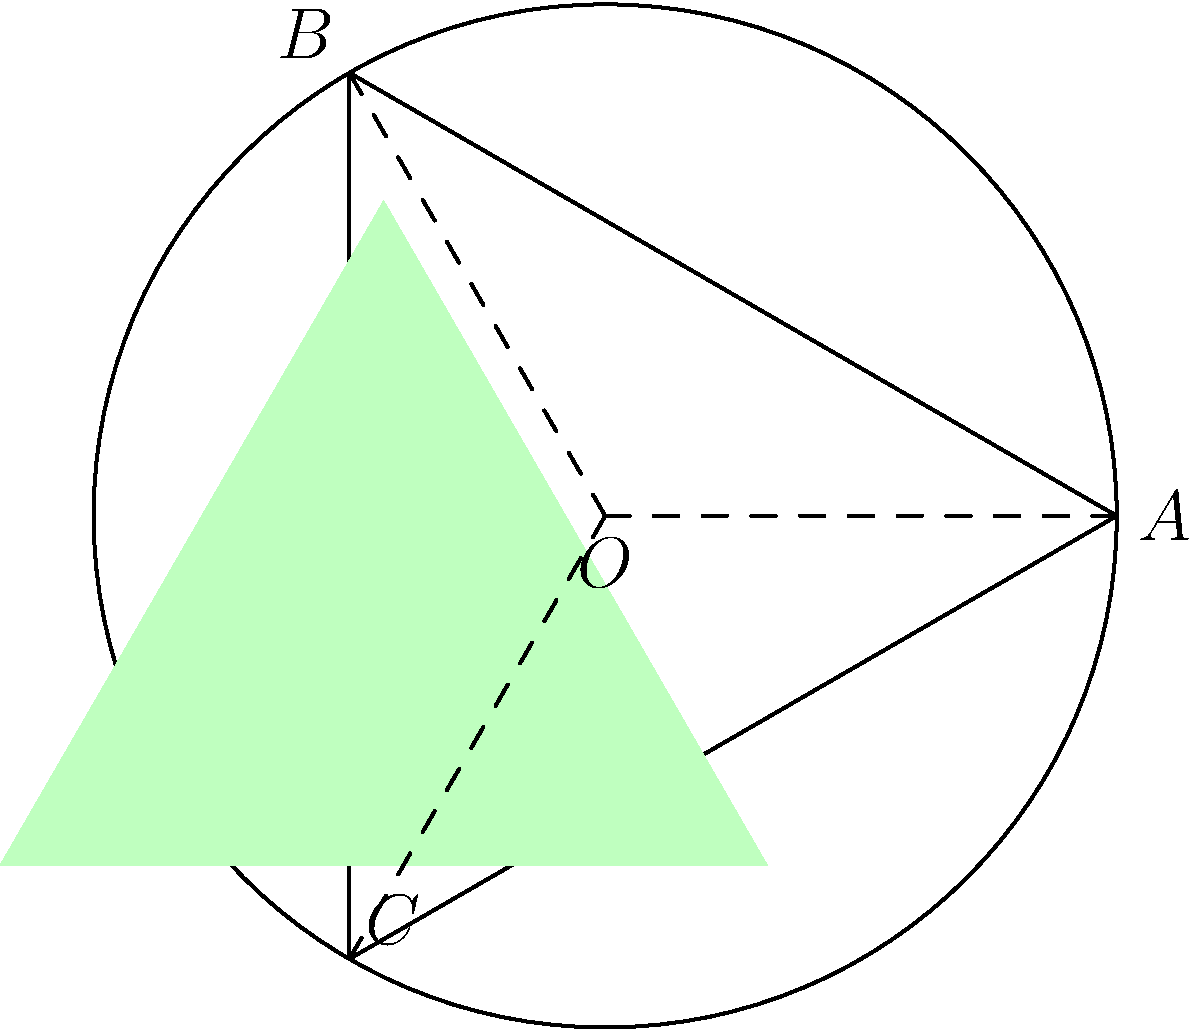In the circular diagram above, an equilateral triangle ABC is inscribed in a circle with center O and radius r. A smaller equilateral triangle (shaded in green) is inscribed within triangle ABC. Compare the area of the shaded triangle to the area of triangle ABC. What fraction of triangle ABC's area does the shaded triangle occupy? Let's approach this step-by-step:

1) First, we need to find the side length of triangle ABC. In an equilateral triangle inscribed in a circle of radius r, the side length is $a = r\sqrt{3}$.

2) The area of triangle ABC is:
   $$A_{ABC} = \frac{\sqrt{3}}{4}a^2 = \frac{\sqrt{3}}{4}(r\sqrt{3})^2 = \frac{3\sqrt{3}}{4}r^2$$

3) Now, let's focus on the shaded triangle. Its vertices are at the midpoints of the sides of triangle ABC.

4) The distance from the midpoint of a side to the opposite vertex in an equilateral triangle is $\frac{\sqrt{3}}{3}$ times the side length. This means the side length of the shaded triangle is:
   $$s = \frac{\sqrt{3}}{3}a = \frac{\sqrt{3}}{3}r\sqrt{3} = r$$

5) The area of the shaded triangle is:
   $$A_{shaded} = \frac{\sqrt{3}}{4}s^2 = \frac{\sqrt{3}}{4}r^2$$

6) To find the fraction of ABC's area that the shaded triangle occupies, we divide:
   $$\frac{A_{shaded}}{A_{ABC}} = \frac{\frac{\sqrt{3}}{4}r^2}{\frac{3\sqrt{3}}{4}r^2} = \frac{1}{3}$$

Therefore, the shaded triangle occupies $\frac{1}{3}$ or one-third of the area of triangle ABC.
Answer: $\frac{1}{3}$ 